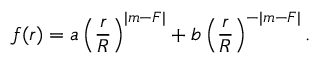Convert formula to latex. <formula><loc_0><loc_0><loc_500><loc_500>f ( r ) = a \left ( \frac { r } { R } \right ) ^ { | m - F | } + b \left ( \frac { r } { R } \right ) ^ { - | m - F | } .</formula> 